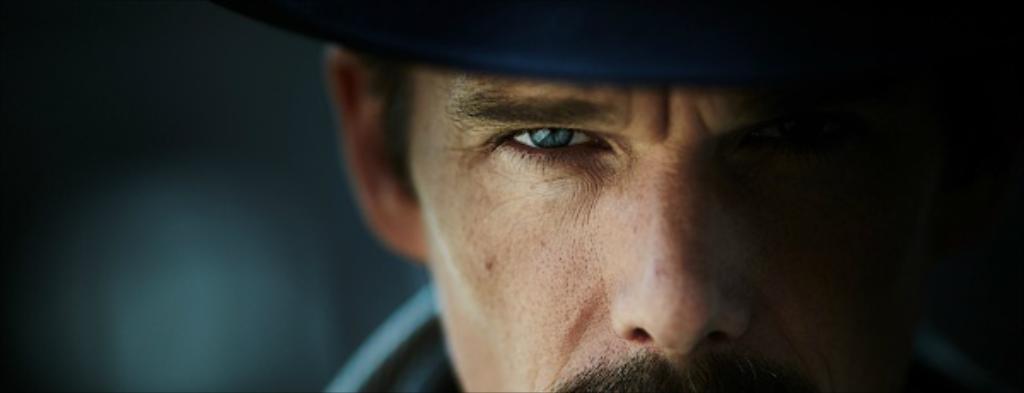Who or what is the main subject in the image? There is a person in the image. What is the person wearing on their head? The person is wearing a blue hat. Can you describe the background of the image? The background of the image is blurred. What type of slip can be seen on the person's feet in the image? There is no slip visible on the person's feet in the image. What is the person trying to stop in the image? There is no indication in the image that the person is trying to stop anything. 